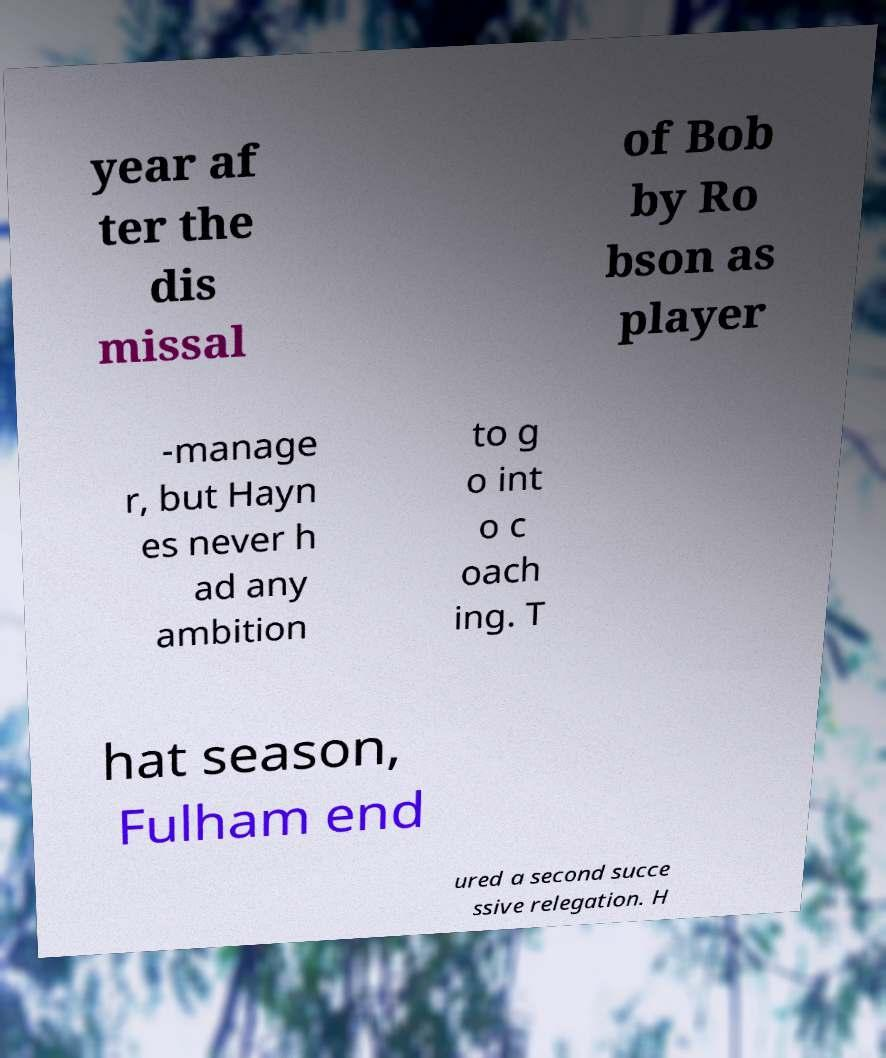Can you accurately transcribe the text from the provided image for me? year af ter the dis missal of Bob by Ro bson as player -manage r, but Hayn es never h ad any ambition to g o int o c oach ing. T hat season, Fulham end ured a second succe ssive relegation. H 